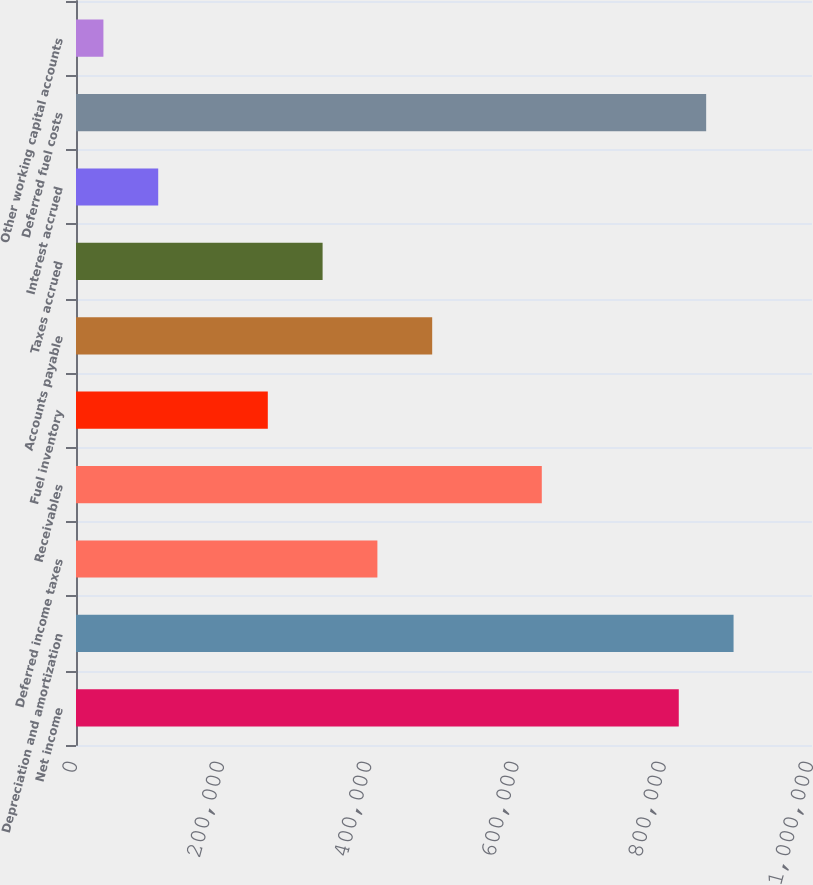Convert chart to OTSL. <chart><loc_0><loc_0><loc_500><loc_500><bar_chart><fcel>Net income<fcel>Depreciation and amortization<fcel>Deferred income taxes<fcel>Receivables<fcel>Fuel inventory<fcel>Accounts payable<fcel>Taxes accrued<fcel>Interest accrued<fcel>Deferred fuel costs<fcel>Other working capital accounts<nl><fcel>818983<fcel>893433<fcel>409504<fcel>632856<fcel>260603<fcel>483955<fcel>335054<fcel>111702<fcel>856208<fcel>37251.3<nl></chart> 